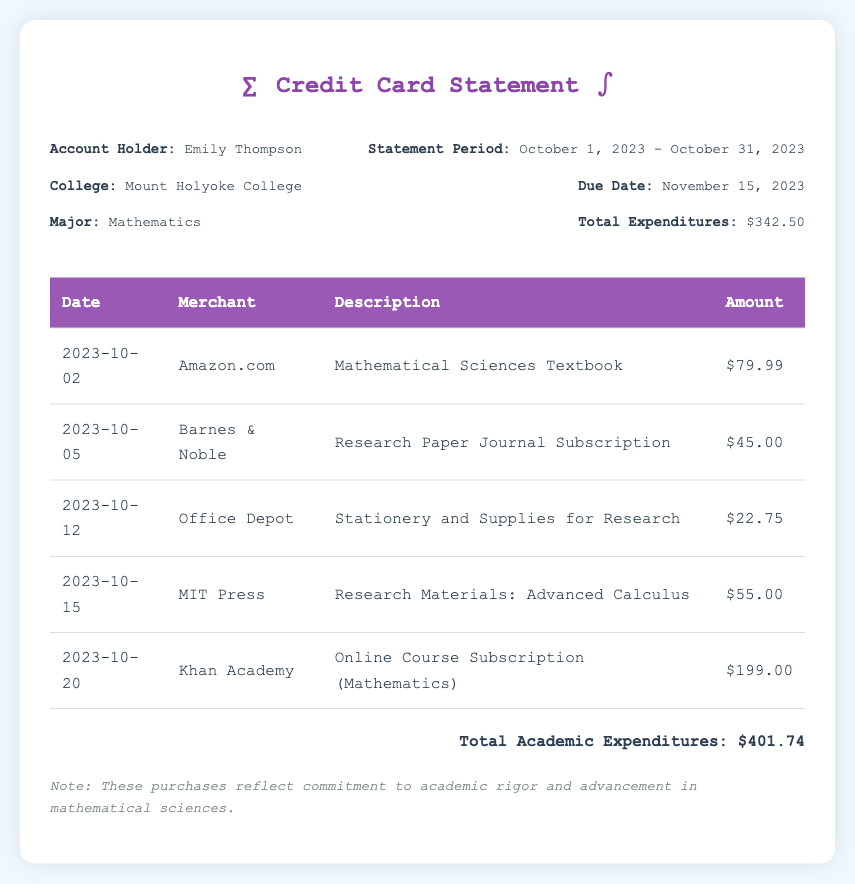what is the account holder's name? The account holder's name is listed under the account information section of the document.
Answer: Emily Thompson what is the statement period? The statement period indicates the range of dates covered by the expenditures listed in the document.
Answer: October 1, 2023 - October 31, 2023 how much was spent on the Mathematical Sciences Textbook? The amount for the Mathematical Sciences Textbook can be found in the transaction details table.
Answer: $79.99 what is the total amount of expenditures? The total expenditures sum up all the individual amounts listed in the document and is provided in the statement details.
Answer: $342.50 how much did Emily spend on the online course subscription? This information can be found in the transaction details table under Khan Academy.
Answer: $199.00 what was the purchase on October 15, 2023? The transaction on this date can be found in the table of expenditures.
Answer: Research Materials: Advanced Calculus what is the total academic expenditures? The total academic expenditures reflect the sum of all academic-related purchases indicated in the document.
Answer: $401.74 what is the due date for the statement? The due date is provided in the statement details section of the document.
Answer: November 15, 2023 what type of statement is this document? This document can be identified as a financial statement summarizing expenditures.
Answer: Credit Card Statement 